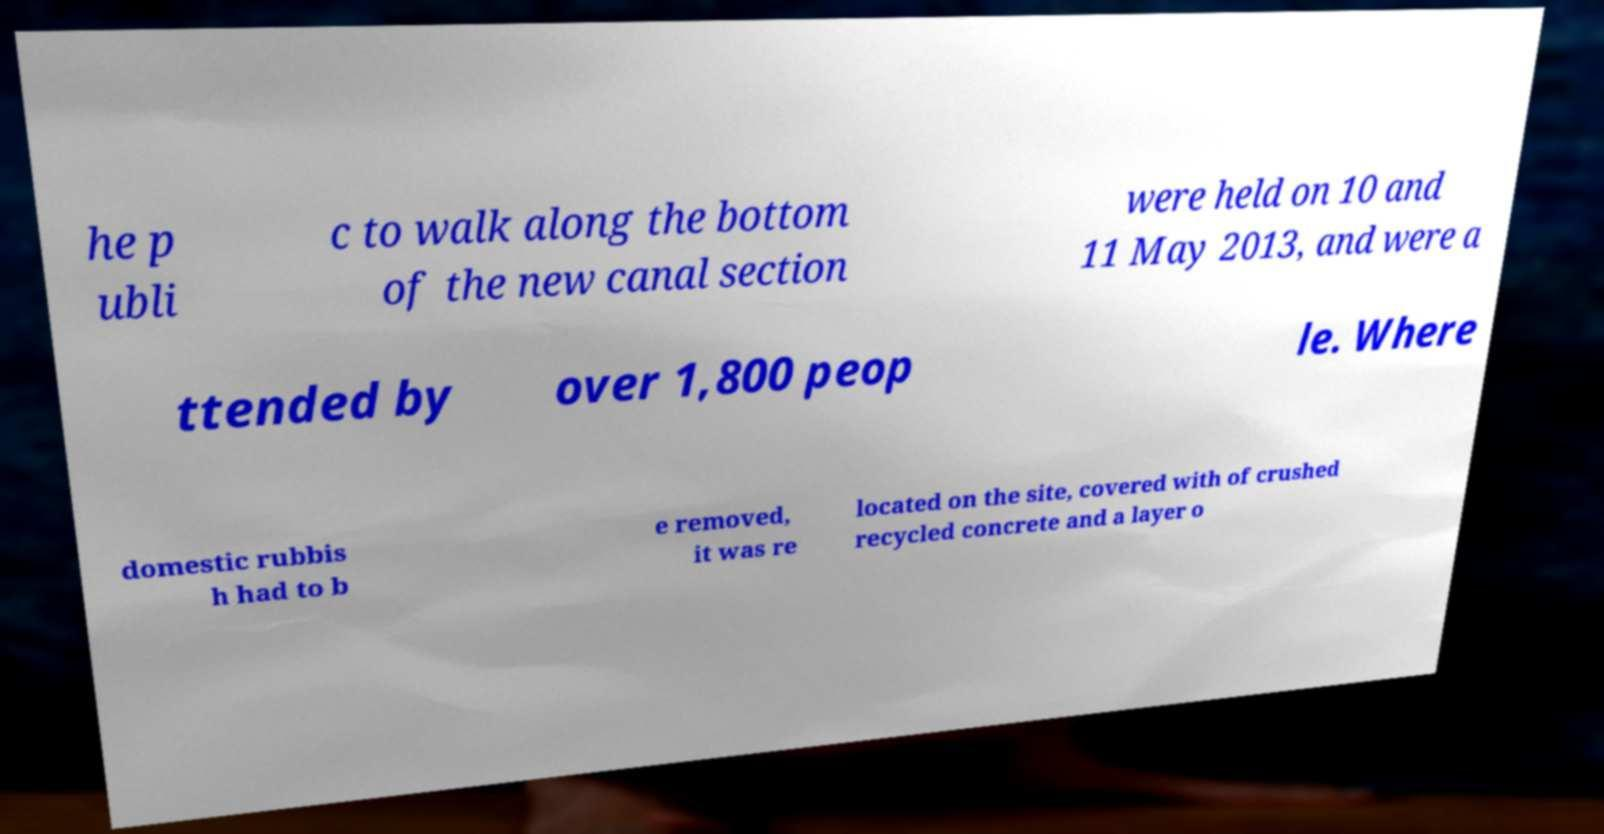There's text embedded in this image that I need extracted. Can you transcribe it verbatim? he p ubli c to walk along the bottom of the new canal section were held on 10 and 11 May 2013, and were a ttended by over 1,800 peop le. Where domestic rubbis h had to b e removed, it was re located on the site, covered with of crushed recycled concrete and a layer o 